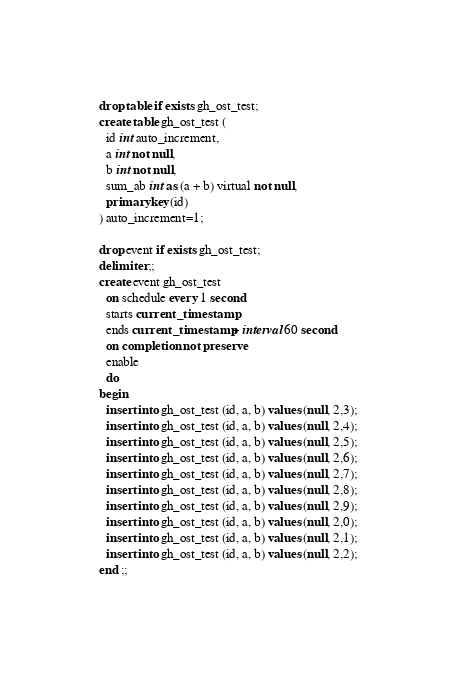<code> <loc_0><loc_0><loc_500><loc_500><_SQL_>drop table if exists gh_ost_test;
create table gh_ost_test (
  id int auto_increment,
  a int not null,
  b int not null,
  sum_ab int as (a + b) virtual not null,
  primary key(id)
) auto_increment=1;

drop event if exists gh_ost_test;
delimiter ;;
create event gh_ost_test
  on schedule every 1 second
  starts current_timestamp
  ends current_timestamp + interval 60 second
  on completion not preserve
  enable
  do
begin
  insert into gh_ost_test (id, a, b) values (null, 2,3);
  insert into gh_ost_test (id, a, b) values (null, 2,4);
  insert into gh_ost_test (id, a, b) values (null, 2,5);
  insert into gh_ost_test (id, a, b) values (null, 2,6);
  insert into gh_ost_test (id, a, b) values (null, 2,7);
  insert into gh_ost_test (id, a, b) values (null, 2,8);
  insert into gh_ost_test (id, a, b) values (null, 2,9);
  insert into gh_ost_test (id, a, b) values (null, 2,0);
  insert into gh_ost_test (id, a, b) values (null, 2,1);
  insert into gh_ost_test (id, a, b) values (null, 2,2);
end ;;
</code> 